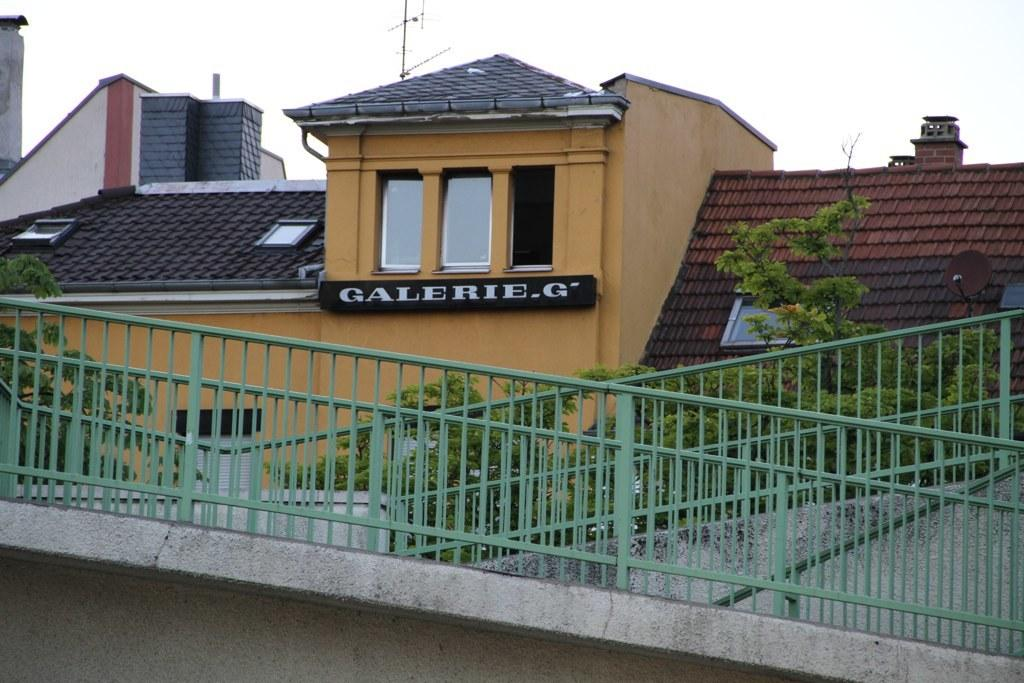What type of structures are present in the image? There are buildings in the image. Can you describe any specific features on one of the buildings? There is a board with text on one of the buildings. What type of architectural element can be seen in the image? Railings are visible in the image. What can be seen in the background of the image? There are trees and the sky visible in the background of the image. How many cents are visible on the board with text in the image? There is no mention of cents or any monetary value on the board with text in the image. 